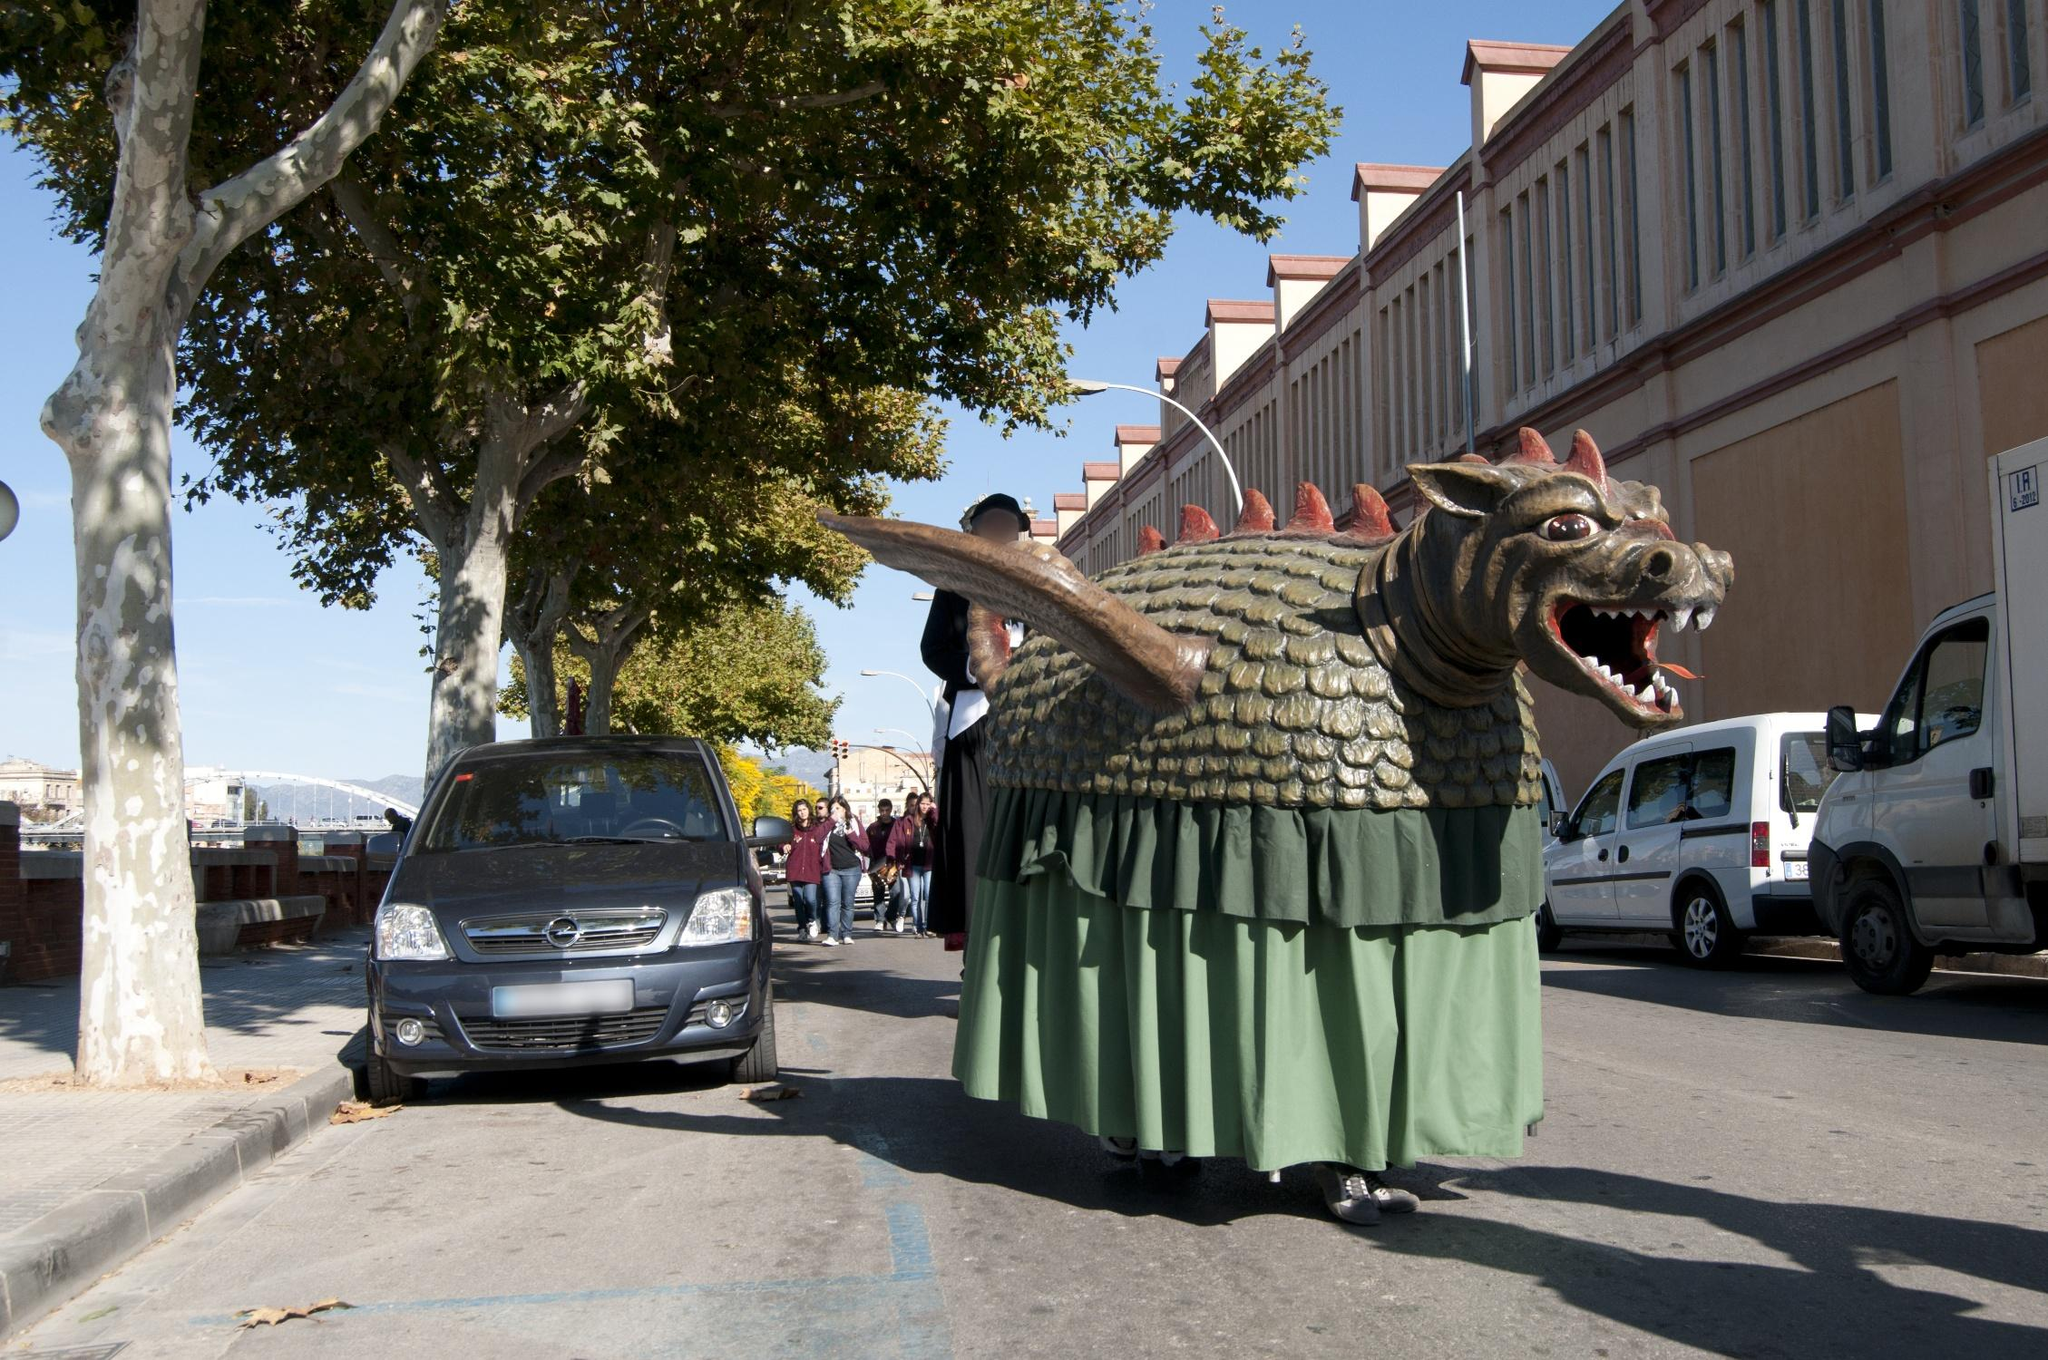Imagine if the dragon float came to life! What would happen next? If the dragon float in the image magically came to life, the once serene street of Barcelona would transform into an exciting scene straight out of a fantasy tale. The dragon, now animated, would stretch its newly flexible body, scales shimmering in the sunlight as it moved. Curious and friendly, the dragon would look around, perhaps playfully interacting with the people around it, causing a mix of awe and exhilaration among both locals and visitors. How would the city and its inhabitants react to such a marvel? Initially, there would be a blend of surprise and apprehension as the city and its inhabitants witness the living dragon. News would spread rapidly, drawing more onlookers and media to the scene. Children, filled with wonder, might approach the dragon with excitement, while adults might proceed with cautious curiosity. The city might organize an impromptu celebration to honor this fantastical occurrence, with musicians, dancers, and street artists adding to the spectacle.

Local authorities and scientists could arrive to study this unprecedented phenomenon, while artists and writers might find inspiration in the dragon, resulting in a surge of creative expressions across the city. The event would foster a sense of unity and shared wonder among the inhabitants, creating a historic moment that would be remembered and narrated for generations to come. What could be the dragon's first message to the people of Barcelona? "Greetings, people of Barcelona! I am Draconis, the guardian of ancient legends. I have come to share tales of old, protect your festivities, and bring magic to your city. Let us celebrate together, in joy and harmony, as we bridge the realms of myth and reality!" 